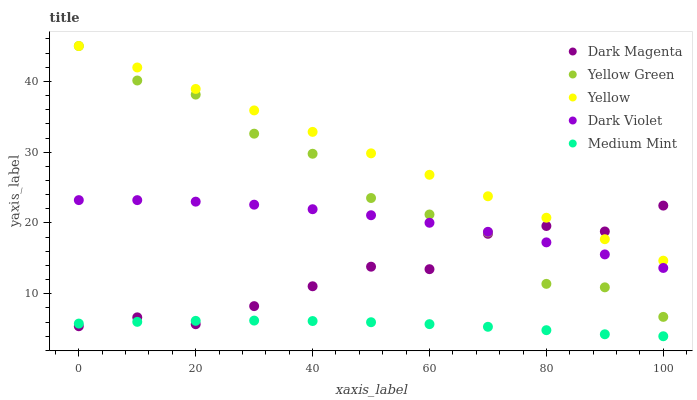Does Medium Mint have the minimum area under the curve?
Answer yes or no. Yes. Does Yellow have the maximum area under the curve?
Answer yes or no. Yes. Does Dark Violet have the minimum area under the curve?
Answer yes or no. No. Does Dark Violet have the maximum area under the curve?
Answer yes or no. No. Is Yellow the smoothest?
Answer yes or no. Yes. Is Yellow Green the roughest?
Answer yes or no. Yes. Is Dark Violet the smoothest?
Answer yes or no. No. Is Dark Violet the roughest?
Answer yes or no. No. Does Medium Mint have the lowest value?
Answer yes or no. Yes. Does Dark Violet have the lowest value?
Answer yes or no. No. Does Yellow Green have the highest value?
Answer yes or no. Yes. Does Dark Violet have the highest value?
Answer yes or no. No. Is Medium Mint less than Dark Violet?
Answer yes or no. Yes. Is Yellow greater than Medium Mint?
Answer yes or no. Yes. Does Dark Violet intersect Dark Magenta?
Answer yes or no. Yes. Is Dark Violet less than Dark Magenta?
Answer yes or no. No. Is Dark Violet greater than Dark Magenta?
Answer yes or no. No. Does Medium Mint intersect Dark Violet?
Answer yes or no. No. 